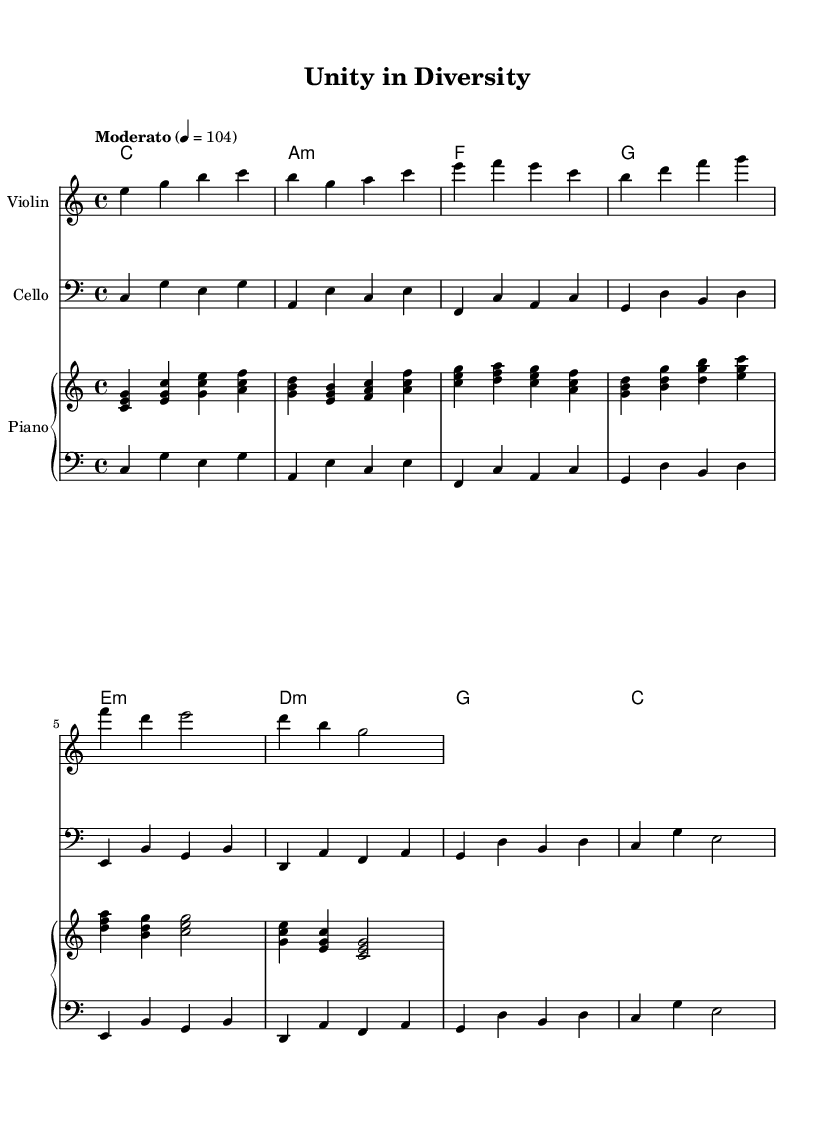What is the key signature of this music? The key signature is C major, which is indicated by the absence of any sharps or flats in the music.
Answer: C major What is the time signature of this music? The time signature is 4/4, denoted at the beginning of the score, meaning there are four beats in each measure.
Answer: 4/4 What is the tempo marking for this piece? The tempo marking specifies "Moderato" and indicates a speed of quarter note = 104, guiding the performance speed.
Answer: Moderato How many different instrumental parts are there in the score? The score consists of four different instrumental parts: Violin, Cello, and two hands of Piano (Right and Left).
Answer: Four What is the first chord presented in the harmonies section? The first chord is C major, as shown in the chord mode notation at the beginning of the harmonies section.
Answer: C Which instrument plays the counter melody? The counter melody is played by the Violin, as indicated in the label for that staff in the score.
Answer: Violin What type of music fusion does this piece represent? This piece represents an electronic-classical fusion, combining elements of both genres to promote social harmony.
Answer: Electronic-classical fusion 